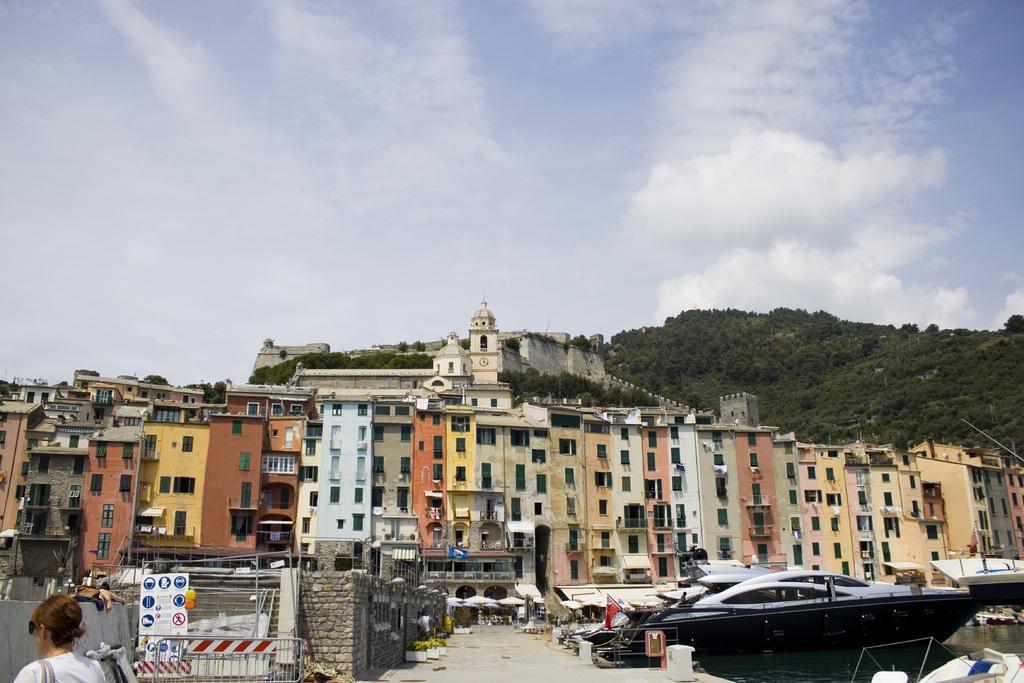Describe this image in one or two sentences. In this image, we can see buildings, trees, hills and vehicles and there is a person wearing glasses and a bag and there are some boards and some other objects and there is water. At the top, there are clouds in the sky. 